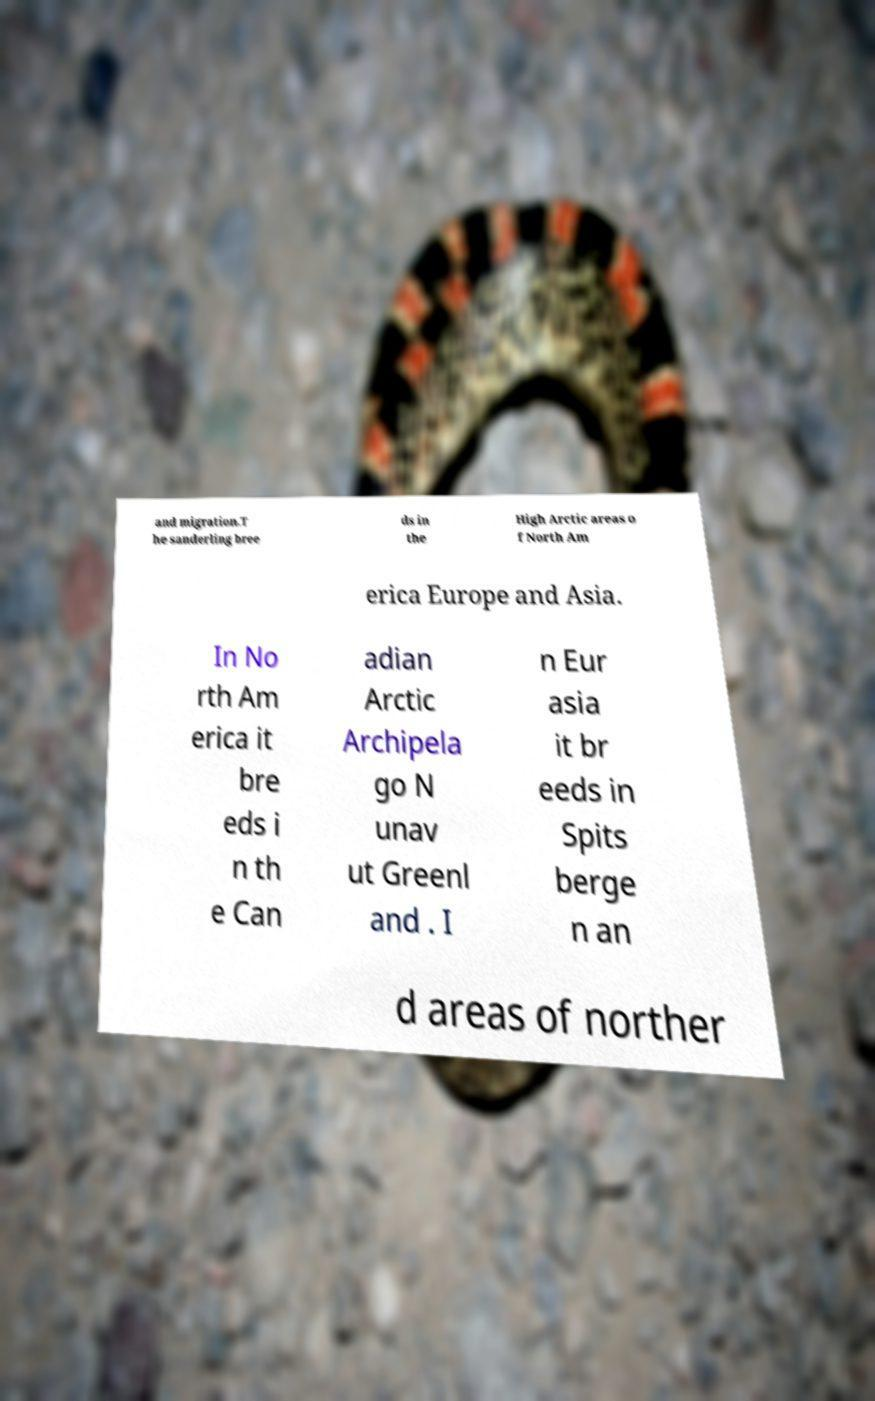Can you accurately transcribe the text from the provided image for me? and migration.T he sanderling bree ds in the High Arctic areas o f North Am erica Europe and Asia. In No rth Am erica it bre eds i n th e Can adian Arctic Archipela go N unav ut Greenl and . I n Eur asia it br eeds in Spits berge n an d areas of norther 